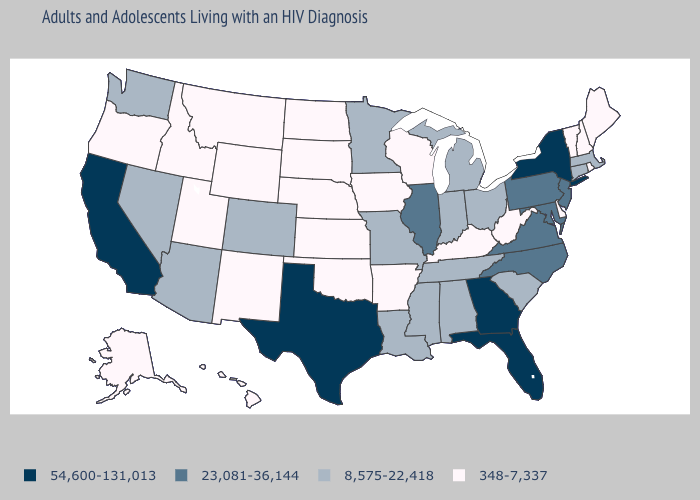What is the value of Mississippi?
Write a very short answer. 8,575-22,418. Does Wisconsin have a lower value than Alabama?
Be succinct. Yes. What is the value of Maine?
Be succinct. 348-7,337. Is the legend a continuous bar?
Keep it brief. No. Does Nebraska have a lower value than South Carolina?
Keep it brief. Yes. What is the highest value in states that border New Jersey?
Give a very brief answer. 54,600-131,013. Name the states that have a value in the range 8,575-22,418?
Short answer required. Alabama, Arizona, Colorado, Connecticut, Indiana, Louisiana, Massachusetts, Michigan, Minnesota, Mississippi, Missouri, Nevada, Ohio, South Carolina, Tennessee, Washington. How many symbols are there in the legend?
Answer briefly. 4. Name the states that have a value in the range 8,575-22,418?
Concise answer only. Alabama, Arizona, Colorado, Connecticut, Indiana, Louisiana, Massachusetts, Michigan, Minnesota, Mississippi, Missouri, Nevada, Ohio, South Carolina, Tennessee, Washington. Does Arkansas have the lowest value in the South?
Write a very short answer. Yes. Among the states that border New Mexico , which have the lowest value?
Write a very short answer. Oklahoma, Utah. Among the states that border Missouri , does Tennessee have the lowest value?
Quick response, please. No. Name the states that have a value in the range 54,600-131,013?
Quick response, please. California, Florida, Georgia, New York, Texas. Name the states that have a value in the range 23,081-36,144?
Short answer required. Illinois, Maryland, New Jersey, North Carolina, Pennsylvania, Virginia. 